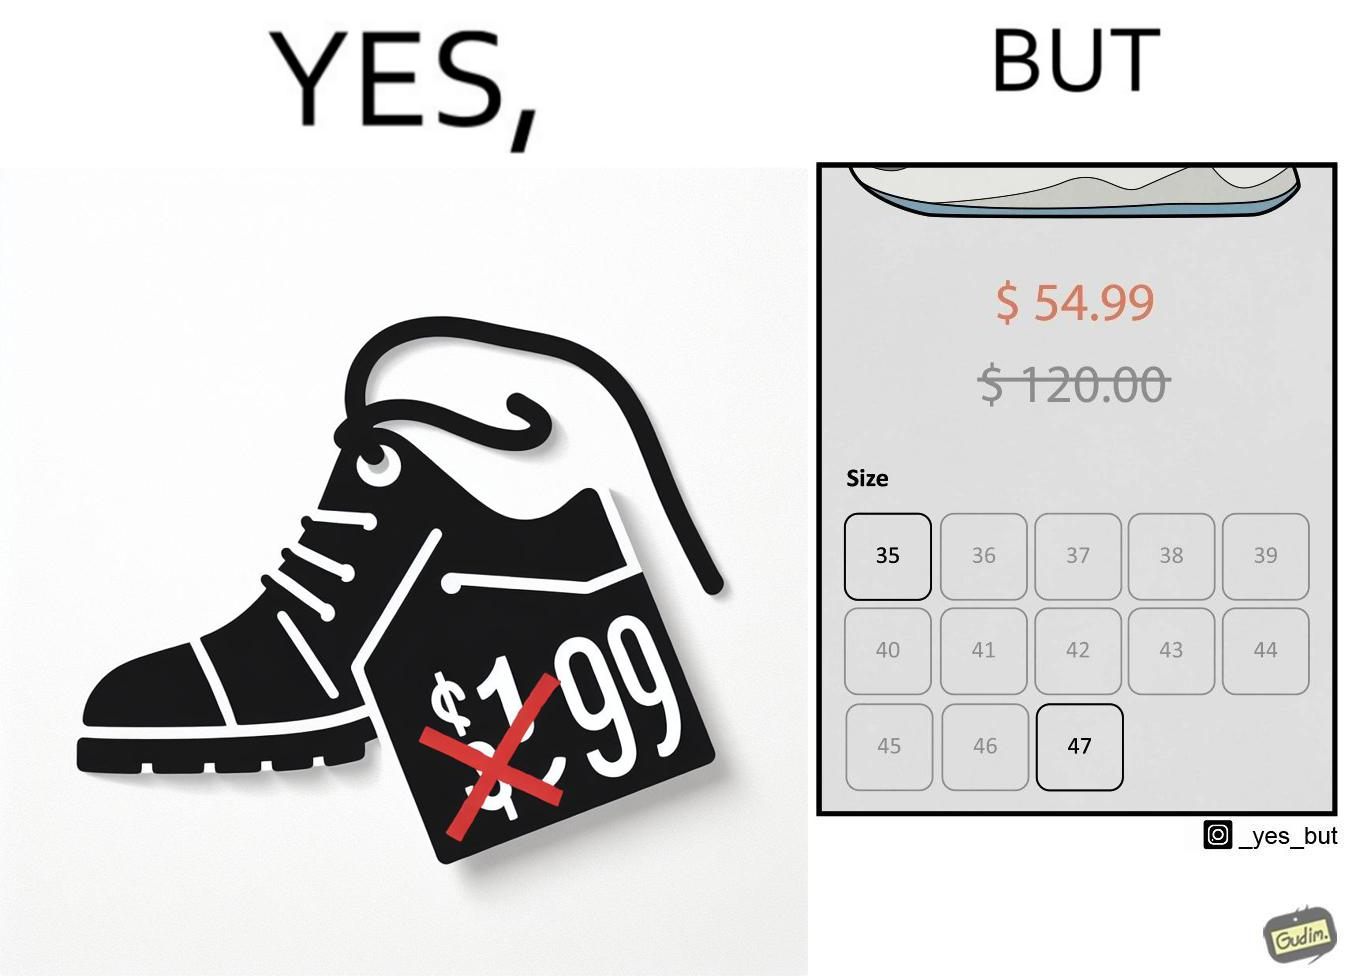What do you see in each half of this image? In the left part of the image: The image shows a shoe. The old of price of the shoe which was $120 has been crossed of and the new price is just $54.99. In the right part of the image: The image shows a part of the shoe, its new price and old, crossed off price and available sizes. The old price was $120 and the new price is $54.99. There are only 2 available sizes which are 35 and 47. These two sizes are the smallest and the largest respectively of all the available sizes. 